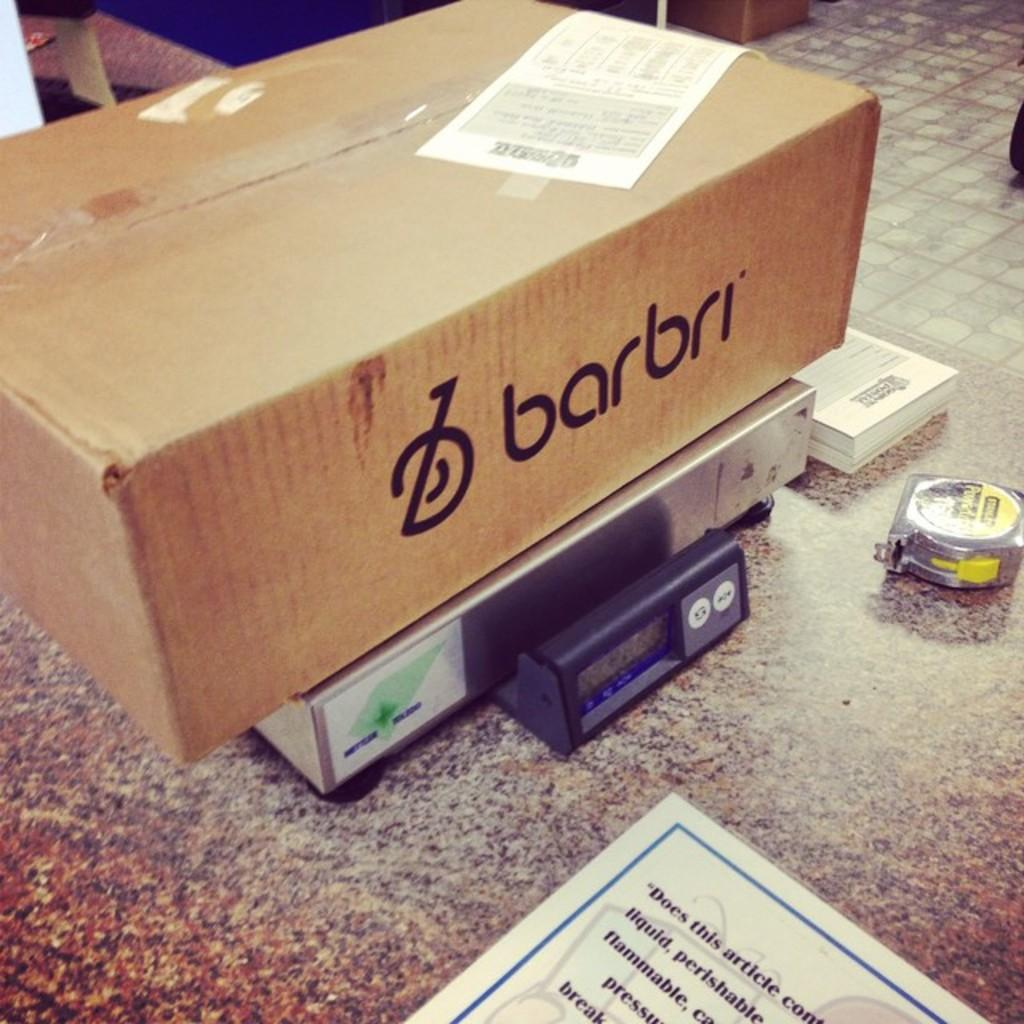Provide a one-sentence caption for the provided image. A box with barbri writting on the side sitting on a postal scale. 